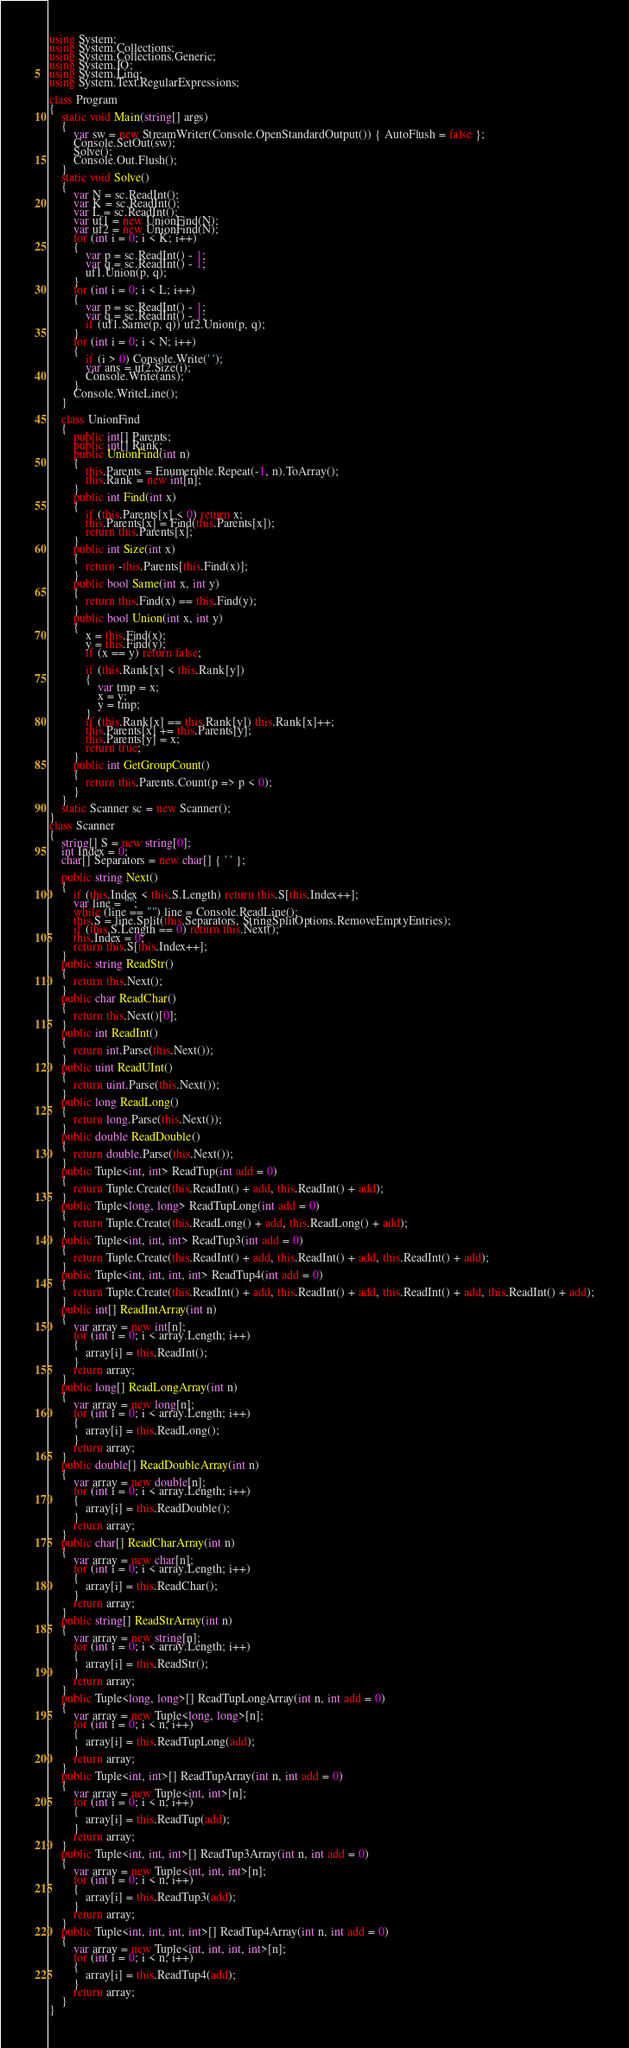<code> <loc_0><loc_0><loc_500><loc_500><_C#_>using System;
using System.Collections;
using System.Collections.Generic;
using System.IO;
using System.Linq;
using System.Text.RegularExpressions;

class Program
{
    static void Main(string[] args)
    {
        var sw = new StreamWriter(Console.OpenStandardOutput()) { AutoFlush = false };
        Console.SetOut(sw);
        Solve();
        Console.Out.Flush();
    }
    static void Solve()
    {
        var N = sc.ReadInt();
        var K = sc.ReadInt();
        var L = sc.ReadInt();
        var uf1 = new UnionFind(N);
        var uf2 = new UnionFind(N);
        for (int i = 0; i < K; i++)
        {
            var p = sc.ReadInt() - 1;
            var q = sc.ReadInt() - 1;
            uf1.Union(p, q);
        }
        for (int i = 0; i < L; i++)
        {
            var p = sc.ReadInt() - 1;
            var q = sc.ReadInt() - 1;
            if (uf1.Same(p, q)) uf2.Union(p, q);
        }
        for (int i = 0; i < N; i++)
        {
            if (i > 0) Console.Write(' ');
            var ans = uf2.Size(i);
            Console.Write(ans);
        }
        Console.WriteLine();
    }

    class UnionFind
    {
        public int[] Parents;
        public int[] Rank;
        public UnionFind(int n)
        {
            this.Parents = Enumerable.Repeat(-1, n).ToArray();
            this.Rank = new int[n];
        }
        public int Find(int x)
        {
            if (this.Parents[x] < 0) return x;
            this.Parents[x] = Find(this.Parents[x]);
            return this.Parents[x];
        }
        public int Size(int x)
        {
            return -this.Parents[this.Find(x)];
        }
        public bool Same(int x, int y)
        {
            return this.Find(x) == this.Find(y);
        }
        public bool Union(int x, int y)
        {
            x = this.Find(x);
            y = this.Find(y);
            if (x == y) return false;

            if (this.Rank[x] < this.Rank[y])
            {
                var tmp = x;
                x = y;
                y = tmp;
            }
            if (this.Rank[x] == this.Rank[y]) this.Rank[x]++;
            this.Parents[x] += this.Parents[y];
            this.Parents[y] = x;
            return true;
        }
        public int GetGroupCount()
        {
            return this.Parents.Count(p => p < 0);
        }
    }
    static Scanner sc = new Scanner();
}
class Scanner
{
    string[] S = new string[0];
    int Index = 0;
    char[] Separators = new char[] { ' ' };

    public string Next()
    {
        if (this.Index < this.S.Length) return this.S[this.Index++];
        var line = "";
        while (line == "") line = Console.ReadLine();
        this.S = line.Split(this.Separators, StringSplitOptions.RemoveEmptyEntries);
        if (this.S.Length == 0) return this.Next();
        this.Index = 0;
        return this.S[this.Index++];
    }
    public string ReadStr()
    {
        return this.Next();
    }
    public char ReadChar()
    {
        return this.Next()[0];
    }
    public int ReadInt()
    {
        return int.Parse(this.Next());
    }
    public uint ReadUInt()
    {
        return uint.Parse(this.Next());
    }
    public long ReadLong()
    {
        return long.Parse(this.Next());
    }
    public double ReadDouble()
    {
        return double.Parse(this.Next());
    }
    public Tuple<int, int> ReadTup(int add = 0)
    {
        return Tuple.Create(this.ReadInt() + add, this.ReadInt() + add);
    }
    public Tuple<long, long> ReadTupLong(int add = 0)
    {
        return Tuple.Create(this.ReadLong() + add, this.ReadLong() + add);
    }
    public Tuple<int, int, int> ReadTup3(int add = 0)
    {
        return Tuple.Create(this.ReadInt() + add, this.ReadInt() + add, this.ReadInt() + add);
    }
    public Tuple<int, int, int, int> ReadTup4(int add = 0)
    {
        return Tuple.Create(this.ReadInt() + add, this.ReadInt() + add, this.ReadInt() + add, this.ReadInt() + add);
    }
    public int[] ReadIntArray(int n)
    {
        var array = new int[n];
        for (int i = 0; i < array.Length; i++)
        {
            array[i] = this.ReadInt();
        }
        return array;
    }
    public long[] ReadLongArray(int n)
    {
        var array = new long[n];
        for (int i = 0; i < array.Length; i++)
        {
            array[i] = this.ReadLong();
        }
        return array;
    }
    public double[] ReadDoubleArray(int n)
    {
        var array = new double[n];
        for (int i = 0; i < array.Length; i++)
        {
            array[i] = this.ReadDouble();
        }
        return array;
    }
    public char[] ReadCharArray(int n)
    {
        var array = new char[n];
        for (int i = 0; i < array.Length; i++)
        {
            array[i] = this.ReadChar();
        }
        return array;
    }
    public string[] ReadStrArray(int n)
    {
        var array = new string[n];
        for (int i = 0; i < array.Length; i++)
        {
            array[i] = this.ReadStr();
        }
        return array;
    }
    public Tuple<long, long>[] ReadTupLongArray(int n, int add = 0)
    {
        var array = new Tuple<long, long>[n];
        for (int i = 0; i < n; i++)
        {
            array[i] = this.ReadTupLong(add);
        }
        return array;
    }
    public Tuple<int, int>[] ReadTupArray(int n, int add = 0)
    {
        var array = new Tuple<int, int>[n];
        for (int i = 0; i < n; i++)
        {
            array[i] = this.ReadTup(add);
        }
        return array;
    }
    public Tuple<int, int, int>[] ReadTup3Array(int n, int add = 0)
    {
        var array = new Tuple<int, int, int>[n];
        for (int i = 0; i < n; i++)
        {
            array[i] = this.ReadTup3(add);
        }
        return array;
    }
    public Tuple<int, int, int, int>[] ReadTup4Array(int n, int add = 0)
    {
        var array = new Tuple<int, int, int, int>[n];
        for (int i = 0; i < n; i++)
        {
            array[i] = this.ReadTup4(add);
        }
        return array;
    }
}
</code> 